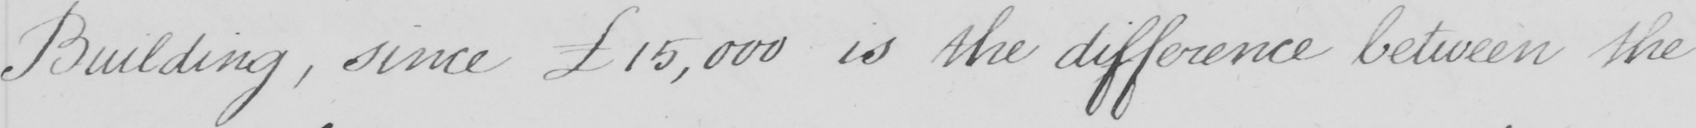Please transcribe the handwritten text in this image. Building , since £15,000 is the difference between the 